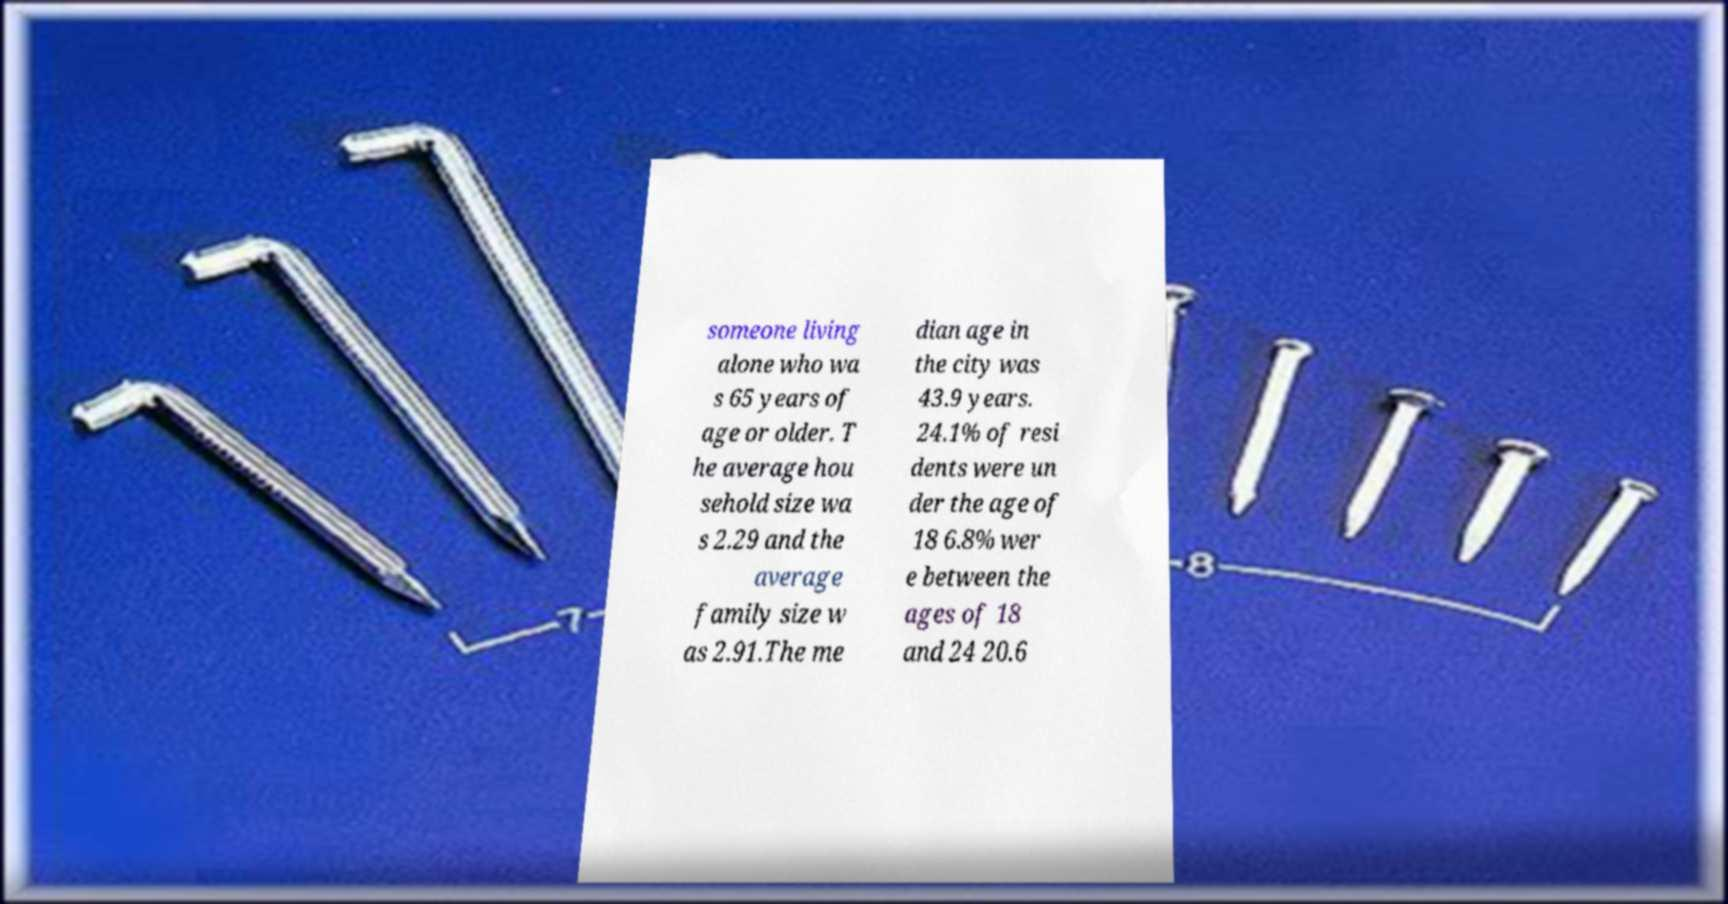Could you extract and type out the text from this image? someone living alone who wa s 65 years of age or older. T he average hou sehold size wa s 2.29 and the average family size w as 2.91.The me dian age in the city was 43.9 years. 24.1% of resi dents were un der the age of 18 6.8% wer e between the ages of 18 and 24 20.6 